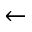Convert formula to latex. <formula><loc_0><loc_0><loc_500><loc_500>\leftarrow</formula> 